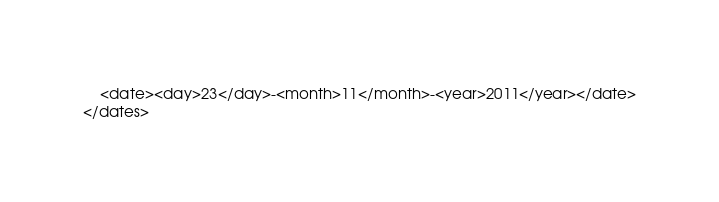Convert code to text. <code><loc_0><loc_0><loc_500><loc_500><_XML_>	<date><day>23</day>-<month>11</month>-<year>2011</year></date>
</dates>
</code> 